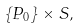<formula> <loc_0><loc_0><loc_500><loc_500>\left \{ P _ { 0 } \right \} \times S ,</formula> 